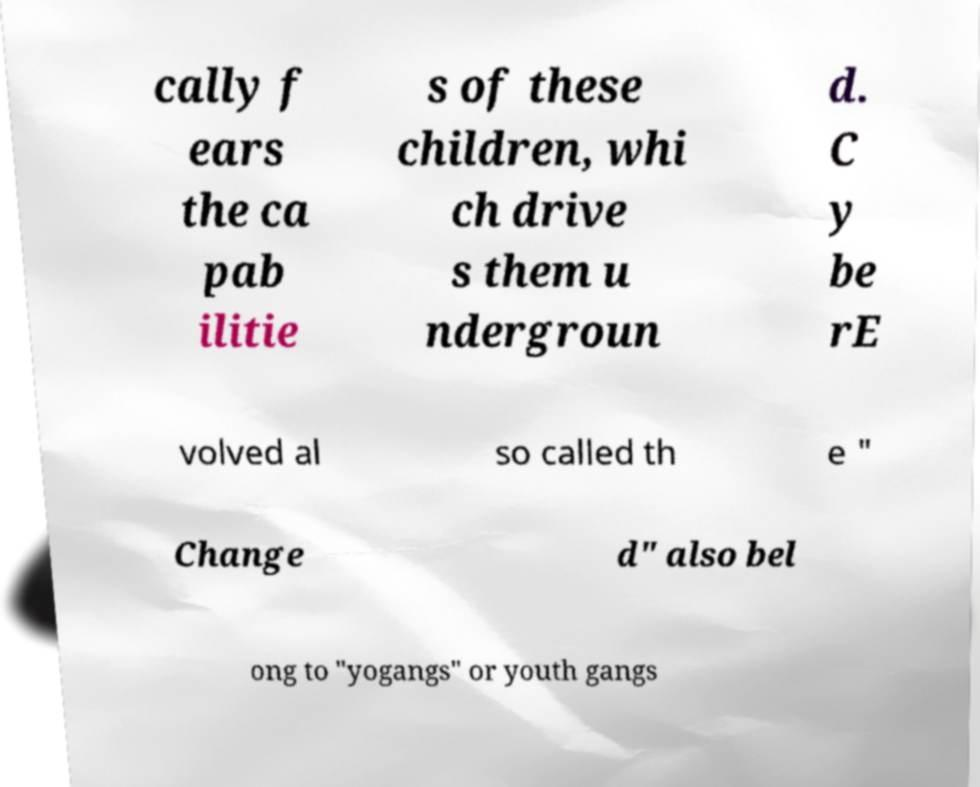Can you read and provide the text displayed in the image?This photo seems to have some interesting text. Can you extract and type it out for me? cally f ears the ca pab ilitie s of these children, whi ch drive s them u ndergroun d. C y be rE volved al so called th e " Change d" also bel ong to "yogangs" or youth gangs 